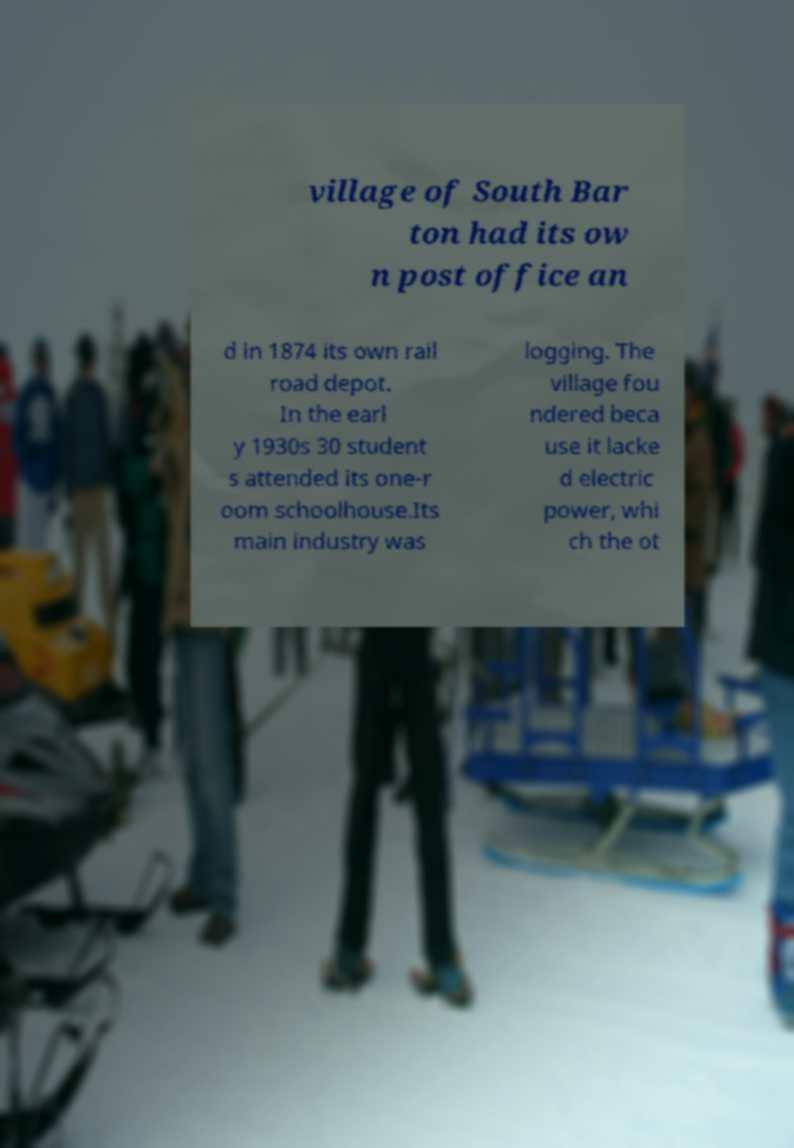For documentation purposes, I need the text within this image transcribed. Could you provide that? village of South Bar ton had its ow n post office an d in 1874 its own rail road depot. In the earl y 1930s 30 student s attended its one-r oom schoolhouse.Its main industry was logging. The village fou ndered beca use it lacke d electric power, whi ch the ot 